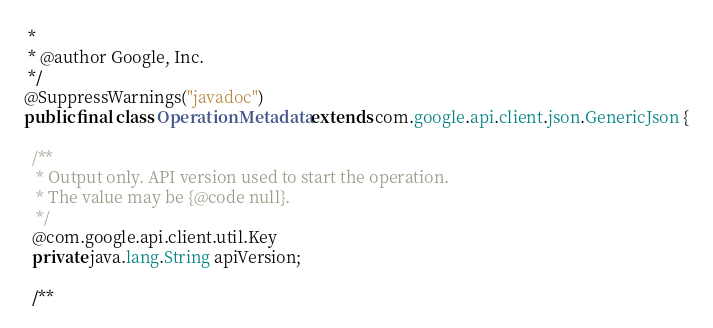<code> <loc_0><loc_0><loc_500><loc_500><_Java_> *
 * @author Google, Inc.
 */
@SuppressWarnings("javadoc")
public final class OperationMetadata extends com.google.api.client.json.GenericJson {

  /**
   * Output only. API version used to start the operation.
   * The value may be {@code null}.
   */
  @com.google.api.client.util.Key
  private java.lang.String apiVersion;

  /**</code> 